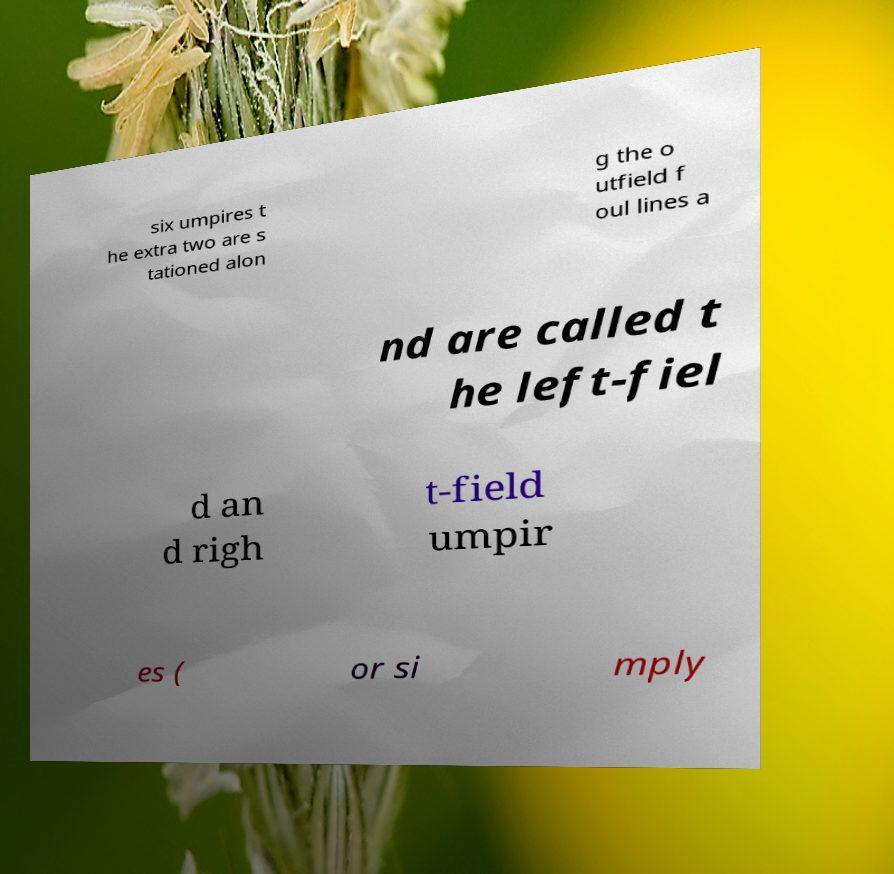Could you assist in decoding the text presented in this image and type it out clearly? six umpires t he extra two are s tationed alon g the o utfield f oul lines a nd are called t he left-fiel d an d righ t-field umpir es ( or si mply 